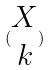<formula> <loc_0><loc_0><loc_500><loc_500>( \begin{matrix} X \\ k \end{matrix} )</formula> 